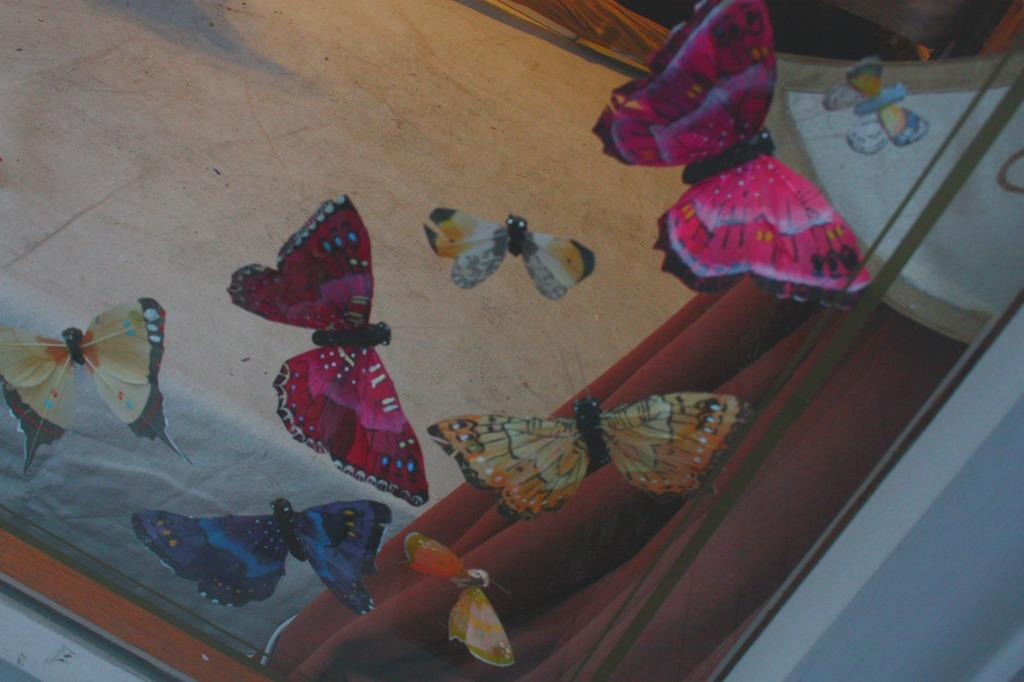What type of window is present in the image? There is a glass window in the image. What decorations are on the window? There are butterfly stickers attached to the window. What can be seen through the window? The floor is visible through the window. Is there any window treatment present in the image? Yes, there is a curtain associated with the window. Can you see any jellyfish swimming in the image? There are no jellyfish present in the image; it features a glass window with butterfly stickers and a curtain. 